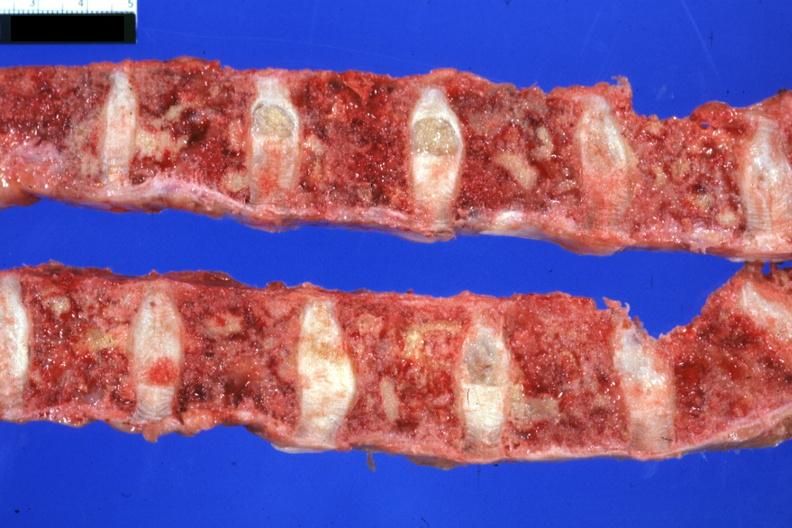how is excellent multiple lesions sigmoid colon papillary adenocarcinoma 6mo post colon resection?
Answer the question using a single word or phrase. Complications 